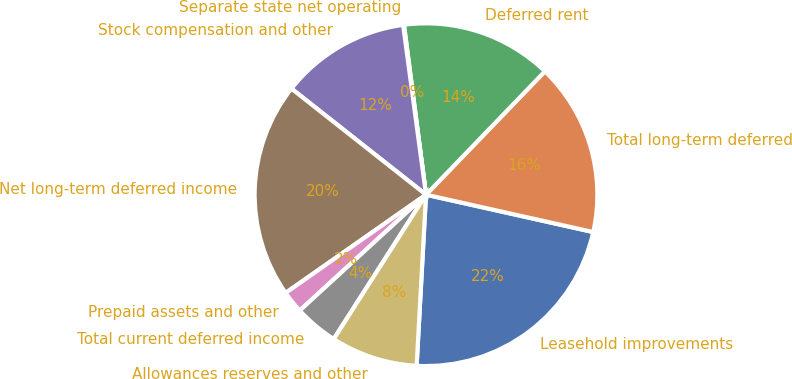Convert chart. <chart><loc_0><loc_0><loc_500><loc_500><pie_chart><fcel>Leasehold improvements<fcel>Total long-term deferred<fcel>Deferred rent<fcel>Separate state net operating<fcel>Stock compensation and other<fcel>Net long-term deferred income<fcel>Prepaid assets and other<fcel>Total current deferred income<fcel>Allowances reserves and other<nl><fcel>22.37%<fcel>16.29%<fcel>14.26%<fcel>0.08%<fcel>12.24%<fcel>20.34%<fcel>2.1%<fcel>4.13%<fcel>8.18%<nl></chart> 